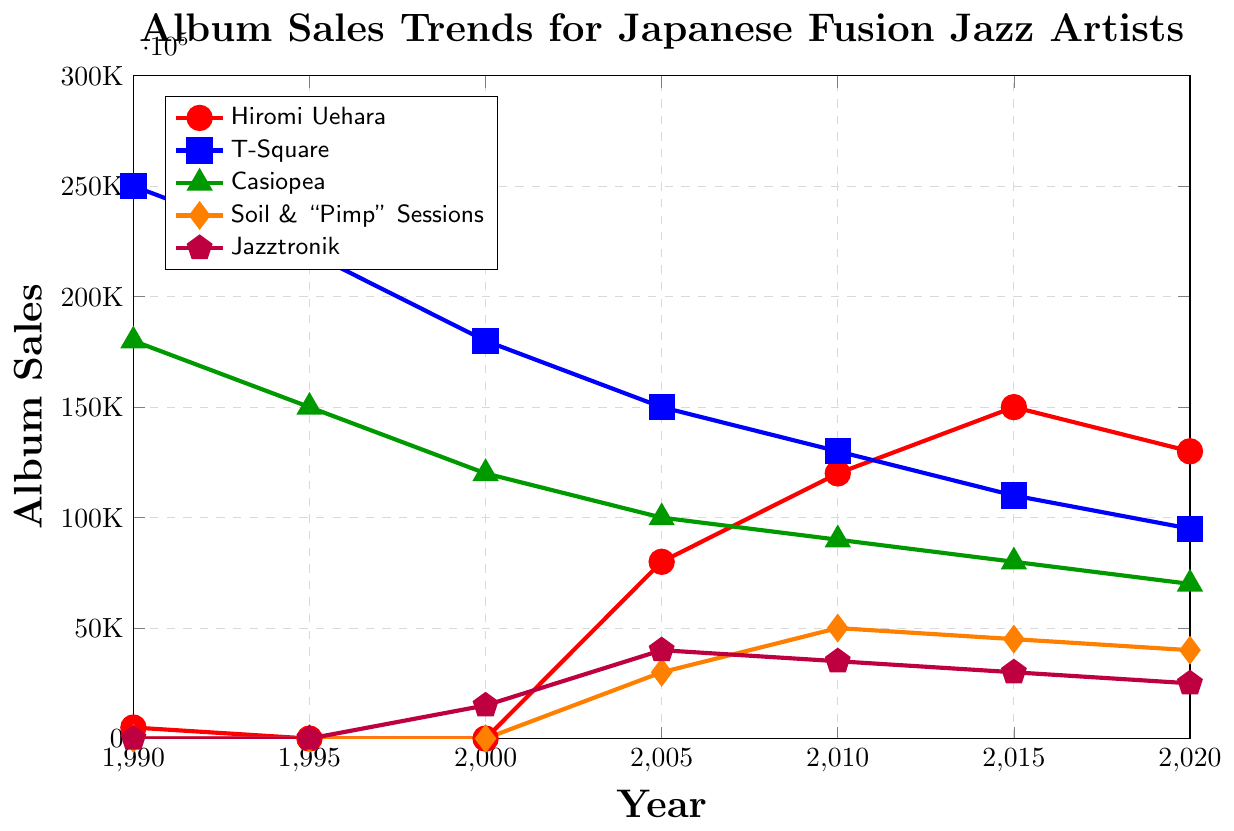What trend can you observe for Hiromi Uehara’s album sales over the last three decades? The sales start very low in 1990, drop to zero for a decade, rise dramatically from 2005, peak in 2015, and slightly decrease in 2020.
Answer: Increasing with minor fluctuations Which artist had the highest album sales in 1990? The blue line (T-Square) is at the highest point in 1990 at 250,000 compared to other artists.
Answer: T-Square In which year did Casiopea and T-Square have the same album sales trend? In 2020, both Casiopea (green) and T-Square (blue) lines converge as their sales are closely similar, with Casiopea slightly lower.
Answer: 2020 By how much did Jazztronik’s album sales change from 2000 to 2005? In 2000, Jazztronik had 15,000 sales, and in 2005, it rose to 40,000. The difference is 40,000 - 15,000 = 25,000.
Answer: 25,000 Which artist experienced a continuous decline in album sales from 1990 to 2020? T-Square's (blue line) album sales steadily dropped from 250,000 in 1990 to 95,000 in 2020.
Answer: T-Square What is the average album sales of Soil & "Pimp" Sessions across all the years provided? Add the sales: 30,000 (2005) + 50,000 (2010) + 45,000 (2015) + 40,000 (2020) = 165,000. The average is 165,000 / 4 = 41,250.
Answer: 41,250 Compare the album sales of Hiromi Uehara and Jazztronik in 2010. Hiromi Uehara's (red) sales were 120,000, while Jazztronik's (purple) sales were 35,000 in 2010.
Answer: Hiromi Uehara had higher sales How has Casiopea's album sales trend changed between 1990 and 2020? Casiopea (green) had 180,000 in 1990, declining steadily to 70,000 by 2020.
Answer: Decreased steadily In what year did Soil & "Pimp" Sessions start recording album sales, and what were the sales that year? The orange line appears in 2005 with album sales of 30,000.
Answer: 2005, 30,000 Calculate the total album sales for T-Square from 1990 to 2020. Sum the sales: 250,000 (1990) + 220,000 (1995) + 180,000 (2000) + 150,000 (2005) + 130,000 (2010) + 110,000 (2015) + 95,000 (2020) = 1,135,000.
Answer: 1,135,000 